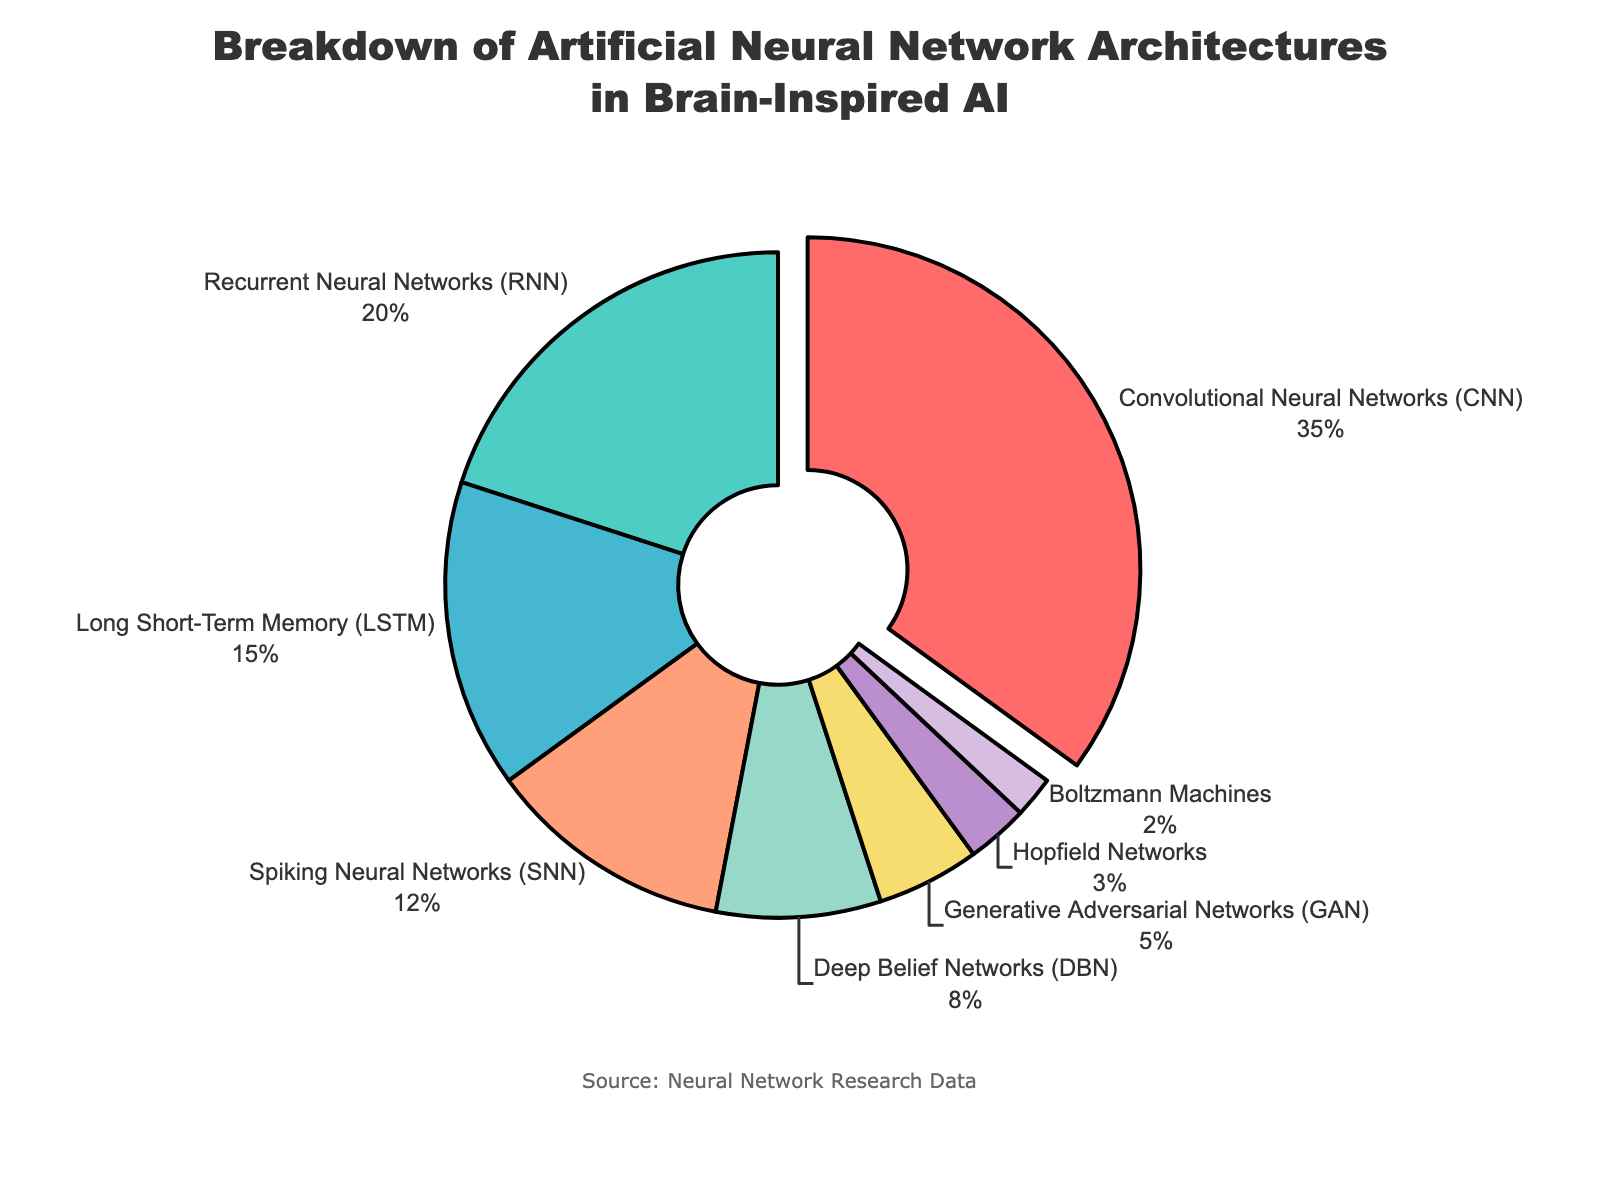What percentage of the architectures used are CNNs and RNNs combined? The percentage of CNNs is 35% and RNNs is 20%. Adding these together gives 35% + 20% = 55%.
Answer: 55% Which architecture has the smallest percentage? The architecture with the smallest percentage is Boltzmann Machines at 2%.
Answer: Boltzmann Machines Which architectures have a percentage difference of 5%? LSTM and DBN have a difference of 15% - 8% = 7%. LSTM and GAN have a difference of 15% - 5% = 10%. DBN and SNN have a difference of 12% - 8% = 4%. DBN and GAN have a difference of 8% - 5% = 3%. Only GAN and Hopfield Networks have a difference of 5% (5% - 3%).
Answer: GAN and Hopfield Networks How much larger is the percentage of SNNs compared to DBNs? The percentage of SNNs is 12% and DBNs is 8%. The difference is 12% - 8% = 4%.
Answer: 4% What is the combined percentage of architectures that have less than 10% usage? The architectures with less than 10% usage are DBN (8%), GAN (5%), Hopfield Networks (3%), and Boltzmann Machines (2%). Adding these gives 8% + 5% + 3% + 2% = 18%.
Answer: 18% What color represents the architecture with the highest percentage? The architecture with the highest percentage is CNNs, represented by the color red.
Answer: Red Which architecture percentages sum up closest to 50%? RNN has 20%, LSTM has 15%, and SNN has 12%. Summing these together gives 20% + 15% + 12% = 47%, which is closest to 50%.
Answer: RNN, LSTM, SNN What percentage more are CNNs over RNNs? The percentage of CNNs is 35% and RNNs is 20%. The difference is 35% - 20% = 15%.
Answer: 15% What is the most common neural network architecture used in brain-inspired AI according to the chart? The most common neural network architecture is CNNs with 35%.
Answer: CNNs Which three architectures have the highest usage percentages? The three architectures with the highest percentages are CNNs (35%), RNNs (20%), and LSTM (15%).
Answer: CNNs, RNNs, LSTM 